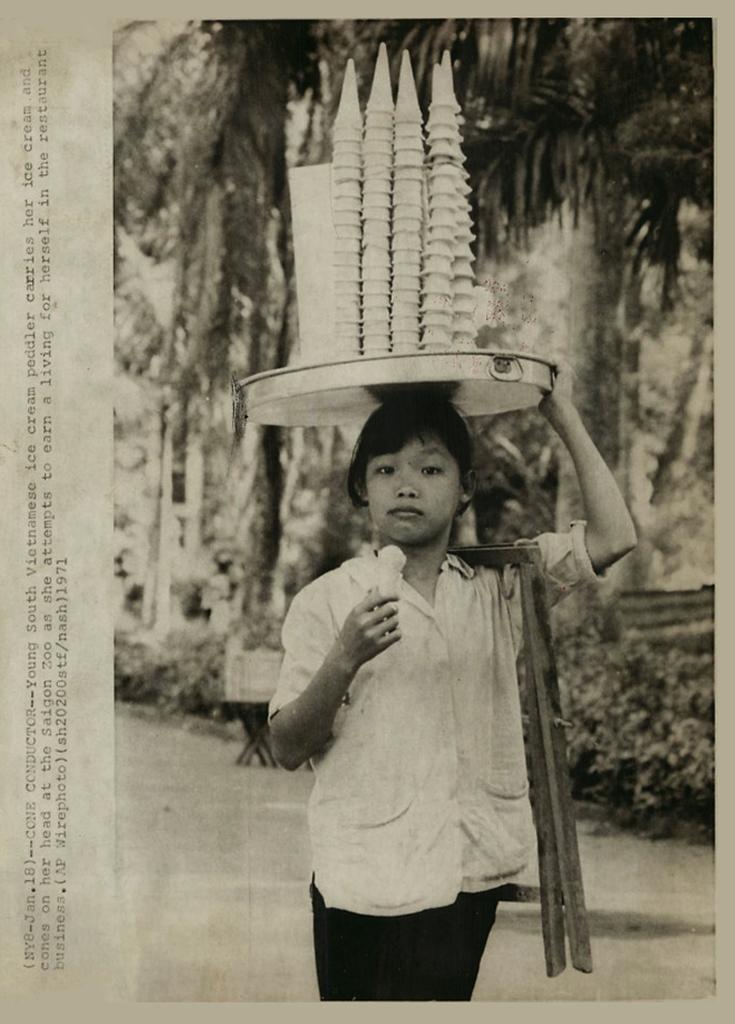Please provide a concise description of this image. In this image we can see a paper, on the paper there is a boy carrying a plate on his head, on the plate there are ice cream cones, also we can see a stand on his shoulder, behind to him, there are plants, and trees, and there are texts on the paper. 